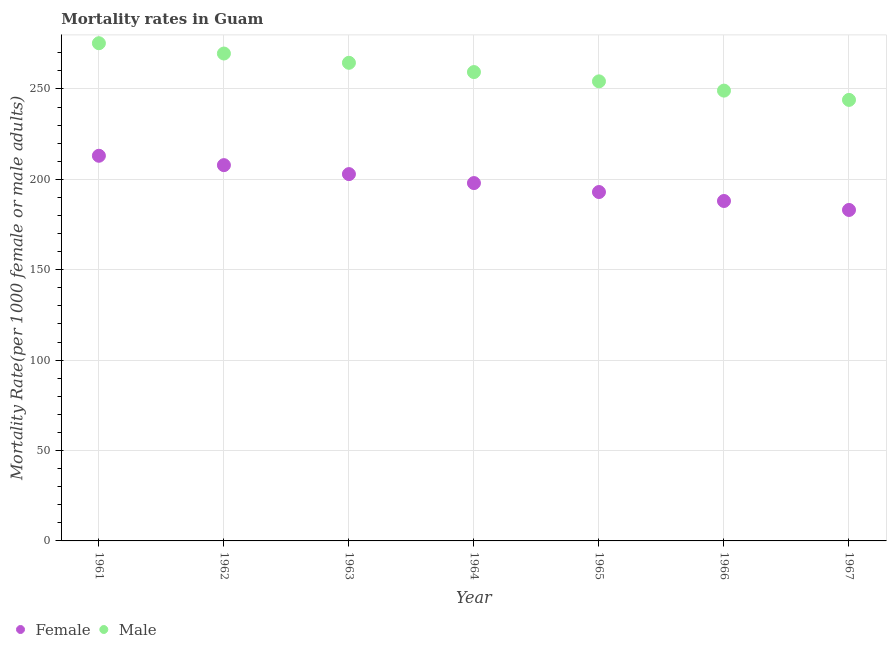How many different coloured dotlines are there?
Keep it short and to the point. 2. Is the number of dotlines equal to the number of legend labels?
Make the answer very short. Yes. What is the female mortality rate in 1964?
Your answer should be very brief. 197.94. Across all years, what is the maximum female mortality rate?
Provide a short and direct response. 213.04. Across all years, what is the minimum female mortality rate?
Provide a short and direct response. 183.07. In which year was the female mortality rate maximum?
Your answer should be compact. 1961. In which year was the male mortality rate minimum?
Provide a short and direct response. 1967. What is the total female mortality rate in the graph?
Offer a terse response. 1385.83. What is the difference between the female mortality rate in 1965 and that in 1966?
Ensure brevity in your answer.  4.96. What is the difference between the male mortality rate in 1965 and the female mortality rate in 1967?
Your answer should be compact. 71.14. What is the average male mortality rate per year?
Give a very brief answer. 259.42. In the year 1962, what is the difference between the male mortality rate and female mortality rate?
Keep it short and to the point. 61.74. What is the ratio of the female mortality rate in 1963 to that in 1966?
Provide a succinct answer. 1.08. Is the female mortality rate in 1965 less than that in 1966?
Ensure brevity in your answer.  No. Is the difference between the female mortality rate in 1961 and 1966 greater than the difference between the male mortality rate in 1961 and 1966?
Make the answer very short. No. What is the difference between the highest and the second highest female mortality rate?
Make the answer very short. 5.18. What is the difference between the highest and the lowest male mortality rate?
Provide a short and direct response. 31.36. In how many years, is the female mortality rate greater than the average female mortality rate taken over all years?
Offer a very short reply. 3. How many dotlines are there?
Offer a very short reply. 2. What is the difference between two consecutive major ticks on the Y-axis?
Offer a terse response. 50. Are the values on the major ticks of Y-axis written in scientific E-notation?
Offer a terse response. No. Does the graph contain any zero values?
Make the answer very short. No. Where does the legend appear in the graph?
Offer a very short reply. Bottom left. How many legend labels are there?
Your answer should be very brief. 2. How are the legend labels stacked?
Give a very brief answer. Horizontal. What is the title of the graph?
Provide a succinct answer. Mortality rates in Guam. Does "Largest city" appear as one of the legend labels in the graph?
Your response must be concise. No. What is the label or title of the X-axis?
Provide a short and direct response. Year. What is the label or title of the Y-axis?
Your answer should be compact. Mortality Rate(per 1000 female or male adults). What is the Mortality Rate(per 1000 female or male adults) in Female in 1961?
Your answer should be very brief. 213.04. What is the Mortality Rate(per 1000 female or male adults) in Male in 1961?
Your answer should be very brief. 275.3. What is the Mortality Rate(per 1000 female or male adults) of Female in 1962?
Make the answer very short. 207.86. What is the Mortality Rate(per 1000 female or male adults) in Male in 1962?
Keep it short and to the point. 269.6. What is the Mortality Rate(per 1000 female or male adults) in Female in 1963?
Your response must be concise. 202.9. What is the Mortality Rate(per 1000 female or male adults) of Male in 1963?
Your answer should be very brief. 264.47. What is the Mortality Rate(per 1000 female or male adults) of Female in 1964?
Keep it short and to the point. 197.94. What is the Mortality Rate(per 1000 female or male adults) of Male in 1964?
Your answer should be very brief. 259.34. What is the Mortality Rate(per 1000 female or male adults) of Female in 1965?
Provide a succinct answer. 192.99. What is the Mortality Rate(per 1000 female or male adults) in Male in 1965?
Your answer should be very brief. 254.21. What is the Mortality Rate(per 1000 female or male adults) of Female in 1966?
Provide a short and direct response. 188.03. What is the Mortality Rate(per 1000 female or male adults) in Male in 1966?
Keep it short and to the point. 249.08. What is the Mortality Rate(per 1000 female or male adults) of Female in 1967?
Provide a succinct answer. 183.07. What is the Mortality Rate(per 1000 female or male adults) in Male in 1967?
Provide a short and direct response. 243.95. Across all years, what is the maximum Mortality Rate(per 1000 female or male adults) in Female?
Keep it short and to the point. 213.04. Across all years, what is the maximum Mortality Rate(per 1000 female or male adults) of Male?
Keep it short and to the point. 275.3. Across all years, what is the minimum Mortality Rate(per 1000 female or male adults) of Female?
Offer a very short reply. 183.07. Across all years, what is the minimum Mortality Rate(per 1000 female or male adults) of Male?
Provide a short and direct response. 243.95. What is the total Mortality Rate(per 1000 female or male adults) of Female in the graph?
Make the answer very short. 1385.83. What is the total Mortality Rate(per 1000 female or male adults) of Male in the graph?
Give a very brief answer. 1815.95. What is the difference between the Mortality Rate(per 1000 female or male adults) in Female in 1961 and that in 1962?
Ensure brevity in your answer.  5.18. What is the difference between the Mortality Rate(per 1000 female or male adults) in Male in 1961 and that in 1962?
Give a very brief answer. 5.7. What is the difference between the Mortality Rate(per 1000 female or male adults) of Female in 1961 and that in 1963?
Offer a very short reply. 10.14. What is the difference between the Mortality Rate(per 1000 female or male adults) of Male in 1961 and that in 1963?
Keep it short and to the point. 10.83. What is the difference between the Mortality Rate(per 1000 female or male adults) in Female in 1961 and that in 1964?
Offer a terse response. 15.1. What is the difference between the Mortality Rate(per 1000 female or male adults) of Male in 1961 and that in 1964?
Offer a terse response. 15.96. What is the difference between the Mortality Rate(per 1000 female or male adults) in Female in 1961 and that in 1965?
Give a very brief answer. 20.06. What is the difference between the Mortality Rate(per 1000 female or male adults) of Male in 1961 and that in 1965?
Give a very brief answer. 21.09. What is the difference between the Mortality Rate(per 1000 female or male adults) of Female in 1961 and that in 1966?
Offer a terse response. 25.01. What is the difference between the Mortality Rate(per 1000 female or male adults) in Male in 1961 and that in 1966?
Ensure brevity in your answer.  26.23. What is the difference between the Mortality Rate(per 1000 female or male adults) in Female in 1961 and that in 1967?
Your answer should be very brief. 29.97. What is the difference between the Mortality Rate(per 1000 female or male adults) in Male in 1961 and that in 1967?
Your answer should be very brief. 31.36. What is the difference between the Mortality Rate(per 1000 female or male adults) of Female in 1962 and that in 1963?
Give a very brief answer. 4.96. What is the difference between the Mortality Rate(per 1000 female or male adults) in Male in 1962 and that in 1963?
Ensure brevity in your answer.  5.13. What is the difference between the Mortality Rate(per 1000 female or male adults) of Female in 1962 and that in 1964?
Your response must be concise. 9.91. What is the difference between the Mortality Rate(per 1000 female or male adults) in Male in 1962 and that in 1964?
Provide a succinct answer. 10.26. What is the difference between the Mortality Rate(per 1000 female or male adults) of Female in 1962 and that in 1965?
Provide a succinct answer. 14.87. What is the difference between the Mortality Rate(per 1000 female or male adults) of Male in 1962 and that in 1965?
Provide a succinct answer. 15.39. What is the difference between the Mortality Rate(per 1000 female or male adults) in Female in 1962 and that in 1966?
Keep it short and to the point. 19.83. What is the difference between the Mortality Rate(per 1000 female or male adults) in Male in 1962 and that in 1966?
Provide a succinct answer. 20.52. What is the difference between the Mortality Rate(per 1000 female or male adults) of Female in 1962 and that in 1967?
Give a very brief answer. 24.79. What is the difference between the Mortality Rate(per 1000 female or male adults) of Male in 1962 and that in 1967?
Your answer should be compact. 25.65. What is the difference between the Mortality Rate(per 1000 female or male adults) in Female in 1963 and that in 1964?
Offer a very short reply. 4.96. What is the difference between the Mortality Rate(per 1000 female or male adults) in Male in 1963 and that in 1964?
Your response must be concise. 5.13. What is the difference between the Mortality Rate(per 1000 female or male adults) in Female in 1963 and that in 1965?
Your response must be concise. 9.91. What is the difference between the Mortality Rate(per 1000 female or male adults) in Male in 1963 and that in 1965?
Ensure brevity in your answer.  10.26. What is the difference between the Mortality Rate(per 1000 female or male adults) of Female in 1963 and that in 1966?
Offer a very short reply. 14.87. What is the difference between the Mortality Rate(per 1000 female or male adults) in Male in 1963 and that in 1966?
Keep it short and to the point. 15.39. What is the difference between the Mortality Rate(per 1000 female or male adults) in Female in 1963 and that in 1967?
Your response must be concise. 19.83. What is the difference between the Mortality Rate(per 1000 female or male adults) in Male in 1963 and that in 1967?
Give a very brief answer. 20.52. What is the difference between the Mortality Rate(per 1000 female or male adults) in Female in 1964 and that in 1965?
Make the answer very short. 4.96. What is the difference between the Mortality Rate(per 1000 female or male adults) of Male in 1964 and that in 1965?
Provide a succinct answer. 5.13. What is the difference between the Mortality Rate(per 1000 female or male adults) in Female in 1964 and that in 1966?
Give a very brief answer. 9.92. What is the difference between the Mortality Rate(per 1000 female or male adults) of Male in 1964 and that in 1966?
Your answer should be compact. 10.26. What is the difference between the Mortality Rate(per 1000 female or male adults) of Female in 1964 and that in 1967?
Provide a succinct answer. 14.87. What is the difference between the Mortality Rate(per 1000 female or male adults) of Male in 1964 and that in 1967?
Keep it short and to the point. 15.39. What is the difference between the Mortality Rate(per 1000 female or male adults) in Female in 1965 and that in 1966?
Your answer should be very brief. 4.96. What is the difference between the Mortality Rate(per 1000 female or male adults) of Male in 1965 and that in 1966?
Give a very brief answer. 5.13. What is the difference between the Mortality Rate(per 1000 female or male adults) in Female in 1965 and that in 1967?
Offer a very short reply. 9.91. What is the difference between the Mortality Rate(per 1000 female or male adults) in Male in 1965 and that in 1967?
Your answer should be compact. 10.26. What is the difference between the Mortality Rate(per 1000 female or male adults) of Female in 1966 and that in 1967?
Give a very brief answer. 4.96. What is the difference between the Mortality Rate(per 1000 female or male adults) of Male in 1966 and that in 1967?
Offer a very short reply. 5.13. What is the difference between the Mortality Rate(per 1000 female or male adults) of Female in 1961 and the Mortality Rate(per 1000 female or male adults) of Male in 1962?
Your response must be concise. -56.56. What is the difference between the Mortality Rate(per 1000 female or male adults) of Female in 1961 and the Mortality Rate(per 1000 female or male adults) of Male in 1963?
Your answer should be compact. -51.43. What is the difference between the Mortality Rate(per 1000 female or male adults) in Female in 1961 and the Mortality Rate(per 1000 female or male adults) in Male in 1964?
Give a very brief answer. -46.3. What is the difference between the Mortality Rate(per 1000 female or male adults) in Female in 1961 and the Mortality Rate(per 1000 female or male adults) in Male in 1965?
Make the answer very short. -41.17. What is the difference between the Mortality Rate(per 1000 female or male adults) in Female in 1961 and the Mortality Rate(per 1000 female or male adults) in Male in 1966?
Your response must be concise. -36.04. What is the difference between the Mortality Rate(per 1000 female or male adults) of Female in 1961 and the Mortality Rate(per 1000 female or male adults) of Male in 1967?
Keep it short and to the point. -30.91. What is the difference between the Mortality Rate(per 1000 female or male adults) in Female in 1962 and the Mortality Rate(per 1000 female or male adults) in Male in 1963?
Ensure brevity in your answer.  -56.61. What is the difference between the Mortality Rate(per 1000 female or male adults) of Female in 1962 and the Mortality Rate(per 1000 female or male adults) of Male in 1964?
Keep it short and to the point. -51.48. What is the difference between the Mortality Rate(per 1000 female or male adults) in Female in 1962 and the Mortality Rate(per 1000 female or male adults) in Male in 1965?
Provide a short and direct response. -46.35. What is the difference between the Mortality Rate(per 1000 female or male adults) in Female in 1962 and the Mortality Rate(per 1000 female or male adults) in Male in 1966?
Ensure brevity in your answer.  -41.22. What is the difference between the Mortality Rate(per 1000 female or male adults) of Female in 1962 and the Mortality Rate(per 1000 female or male adults) of Male in 1967?
Ensure brevity in your answer.  -36.09. What is the difference between the Mortality Rate(per 1000 female or male adults) in Female in 1963 and the Mortality Rate(per 1000 female or male adults) in Male in 1964?
Ensure brevity in your answer.  -56.44. What is the difference between the Mortality Rate(per 1000 female or male adults) in Female in 1963 and the Mortality Rate(per 1000 female or male adults) in Male in 1965?
Provide a succinct answer. -51.31. What is the difference between the Mortality Rate(per 1000 female or male adults) in Female in 1963 and the Mortality Rate(per 1000 female or male adults) in Male in 1966?
Offer a terse response. -46.18. What is the difference between the Mortality Rate(per 1000 female or male adults) of Female in 1963 and the Mortality Rate(per 1000 female or male adults) of Male in 1967?
Offer a terse response. -41.05. What is the difference between the Mortality Rate(per 1000 female or male adults) in Female in 1964 and the Mortality Rate(per 1000 female or male adults) in Male in 1965?
Make the answer very short. -56.27. What is the difference between the Mortality Rate(per 1000 female or male adults) of Female in 1964 and the Mortality Rate(per 1000 female or male adults) of Male in 1966?
Your response must be concise. -51.13. What is the difference between the Mortality Rate(per 1000 female or male adults) of Female in 1964 and the Mortality Rate(per 1000 female or male adults) of Male in 1967?
Offer a terse response. -46. What is the difference between the Mortality Rate(per 1000 female or male adults) of Female in 1965 and the Mortality Rate(per 1000 female or male adults) of Male in 1966?
Give a very brief answer. -56.09. What is the difference between the Mortality Rate(per 1000 female or male adults) of Female in 1965 and the Mortality Rate(per 1000 female or male adults) of Male in 1967?
Offer a very short reply. -50.96. What is the difference between the Mortality Rate(per 1000 female or male adults) in Female in 1966 and the Mortality Rate(per 1000 female or male adults) in Male in 1967?
Your answer should be compact. -55.92. What is the average Mortality Rate(per 1000 female or male adults) in Female per year?
Offer a terse response. 197.98. What is the average Mortality Rate(per 1000 female or male adults) of Male per year?
Make the answer very short. 259.42. In the year 1961, what is the difference between the Mortality Rate(per 1000 female or male adults) of Female and Mortality Rate(per 1000 female or male adults) of Male?
Your answer should be compact. -62.26. In the year 1962, what is the difference between the Mortality Rate(per 1000 female or male adults) of Female and Mortality Rate(per 1000 female or male adults) of Male?
Your answer should be very brief. -61.74. In the year 1963, what is the difference between the Mortality Rate(per 1000 female or male adults) in Female and Mortality Rate(per 1000 female or male adults) in Male?
Your answer should be compact. -61.57. In the year 1964, what is the difference between the Mortality Rate(per 1000 female or male adults) of Female and Mortality Rate(per 1000 female or male adults) of Male?
Provide a short and direct response. -61.4. In the year 1965, what is the difference between the Mortality Rate(per 1000 female or male adults) of Female and Mortality Rate(per 1000 female or male adults) of Male?
Your response must be concise. -61.22. In the year 1966, what is the difference between the Mortality Rate(per 1000 female or male adults) in Female and Mortality Rate(per 1000 female or male adults) in Male?
Provide a short and direct response. -61.05. In the year 1967, what is the difference between the Mortality Rate(per 1000 female or male adults) in Female and Mortality Rate(per 1000 female or male adults) in Male?
Ensure brevity in your answer.  -60.88. What is the ratio of the Mortality Rate(per 1000 female or male adults) in Female in 1961 to that in 1962?
Provide a short and direct response. 1.02. What is the ratio of the Mortality Rate(per 1000 female or male adults) of Male in 1961 to that in 1962?
Your answer should be compact. 1.02. What is the ratio of the Mortality Rate(per 1000 female or male adults) in Female in 1961 to that in 1963?
Provide a short and direct response. 1.05. What is the ratio of the Mortality Rate(per 1000 female or male adults) in Male in 1961 to that in 1963?
Make the answer very short. 1.04. What is the ratio of the Mortality Rate(per 1000 female or male adults) in Female in 1961 to that in 1964?
Ensure brevity in your answer.  1.08. What is the ratio of the Mortality Rate(per 1000 female or male adults) of Male in 1961 to that in 1964?
Ensure brevity in your answer.  1.06. What is the ratio of the Mortality Rate(per 1000 female or male adults) of Female in 1961 to that in 1965?
Provide a short and direct response. 1.1. What is the ratio of the Mortality Rate(per 1000 female or male adults) in Male in 1961 to that in 1965?
Your response must be concise. 1.08. What is the ratio of the Mortality Rate(per 1000 female or male adults) in Female in 1961 to that in 1966?
Your answer should be compact. 1.13. What is the ratio of the Mortality Rate(per 1000 female or male adults) of Male in 1961 to that in 1966?
Give a very brief answer. 1.11. What is the ratio of the Mortality Rate(per 1000 female or male adults) of Female in 1961 to that in 1967?
Your answer should be compact. 1.16. What is the ratio of the Mortality Rate(per 1000 female or male adults) of Male in 1961 to that in 1967?
Keep it short and to the point. 1.13. What is the ratio of the Mortality Rate(per 1000 female or male adults) of Female in 1962 to that in 1963?
Your answer should be compact. 1.02. What is the ratio of the Mortality Rate(per 1000 female or male adults) of Male in 1962 to that in 1963?
Provide a succinct answer. 1.02. What is the ratio of the Mortality Rate(per 1000 female or male adults) of Female in 1962 to that in 1964?
Keep it short and to the point. 1.05. What is the ratio of the Mortality Rate(per 1000 female or male adults) of Male in 1962 to that in 1964?
Provide a succinct answer. 1.04. What is the ratio of the Mortality Rate(per 1000 female or male adults) in Female in 1962 to that in 1965?
Your response must be concise. 1.08. What is the ratio of the Mortality Rate(per 1000 female or male adults) in Male in 1962 to that in 1965?
Offer a very short reply. 1.06. What is the ratio of the Mortality Rate(per 1000 female or male adults) in Female in 1962 to that in 1966?
Your answer should be compact. 1.11. What is the ratio of the Mortality Rate(per 1000 female or male adults) in Male in 1962 to that in 1966?
Your response must be concise. 1.08. What is the ratio of the Mortality Rate(per 1000 female or male adults) in Female in 1962 to that in 1967?
Keep it short and to the point. 1.14. What is the ratio of the Mortality Rate(per 1000 female or male adults) of Male in 1962 to that in 1967?
Provide a short and direct response. 1.11. What is the ratio of the Mortality Rate(per 1000 female or male adults) in Female in 1963 to that in 1964?
Your answer should be very brief. 1.02. What is the ratio of the Mortality Rate(per 1000 female or male adults) in Male in 1963 to that in 1964?
Offer a very short reply. 1.02. What is the ratio of the Mortality Rate(per 1000 female or male adults) in Female in 1963 to that in 1965?
Offer a very short reply. 1.05. What is the ratio of the Mortality Rate(per 1000 female or male adults) of Male in 1963 to that in 1965?
Your answer should be compact. 1.04. What is the ratio of the Mortality Rate(per 1000 female or male adults) in Female in 1963 to that in 1966?
Your answer should be very brief. 1.08. What is the ratio of the Mortality Rate(per 1000 female or male adults) in Male in 1963 to that in 1966?
Offer a terse response. 1.06. What is the ratio of the Mortality Rate(per 1000 female or male adults) in Female in 1963 to that in 1967?
Your response must be concise. 1.11. What is the ratio of the Mortality Rate(per 1000 female or male adults) of Male in 1963 to that in 1967?
Offer a terse response. 1.08. What is the ratio of the Mortality Rate(per 1000 female or male adults) in Female in 1964 to that in 1965?
Ensure brevity in your answer.  1.03. What is the ratio of the Mortality Rate(per 1000 female or male adults) of Male in 1964 to that in 1965?
Keep it short and to the point. 1.02. What is the ratio of the Mortality Rate(per 1000 female or male adults) in Female in 1964 to that in 1966?
Give a very brief answer. 1.05. What is the ratio of the Mortality Rate(per 1000 female or male adults) of Male in 1964 to that in 1966?
Give a very brief answer. 1.04. What is the ratio of the Mortality Rate(per 1000 female or male adults) of Female in 1964 to that in 1967?
Provide a succinct answer. 1.08. What is the ratio of the Mortality Rate(per 1000 female or male adults) in Male in 1964 to that in 1967?
Give a very brief answer. 1.06. What is the ratio of the Mortality Rate(per 1000 female or male adults) in Female in 1965 to that in 1966?
Keep it short and to the point. 1.03. What is the ratio of the Mortality Rate(per 1000 female or male adults) in Male in 1965 to that in 1966?
Make the answer very short. 1.02. What is the ratio of the Mortality Rate(per 1000 female or male adults) of Female in 1965 to that in 1967?
Provide a succinct answer. 1.05. What is the ratio of the Mortality Rate(per 1000 female or male adults) of Male in 1965 to that in 1967?
Keep it short and to the point. 1.04. What is the ratio of the Mortality Rate(per 1000 female or male adults) of Female in 1966 to that in 1967?
Make the answer very short. 1.03. What is the difference between the highest and the second highest Mortality Rate(per 1000 female or male adults) of Female?
Your answer should be compact. 5.18. What is the difference between the highest and the second highest Mortality Rate(per 1000 female or male adults) in Male?
Your answer should be compact. 5.7. What is the difference between the highest and the lowest Mortality Rate(per 1000 female or male adults) of Female?
Make the answer very short. 29.97. What is the difference between the highest and the lowest Mortality Rate(per 1000 female or male adults) in Male?
Provide a succinct answer. 31.36. 